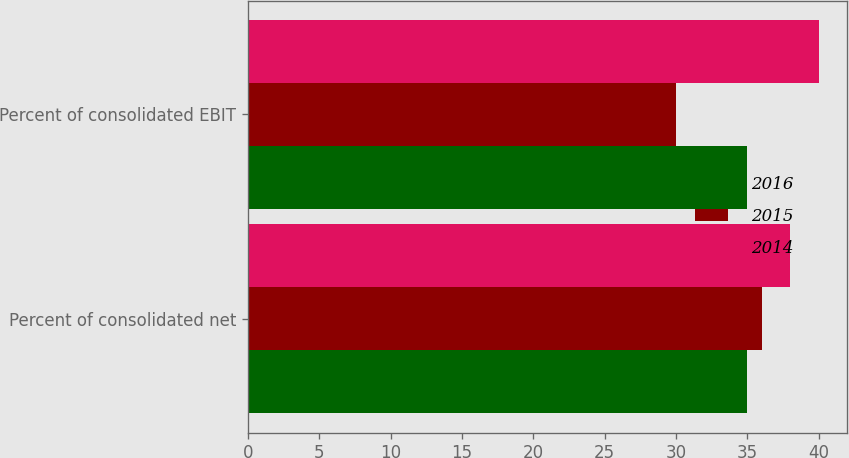Convert chart to OTSL. <chart><loc_0><loc_0><loc_500><loc_500><stacked_bar_chart><ecel><fcel>Percent of consolidated net<fcel>Percent of consolidated EBIT<nl><fcel>2016<fcel>35<fcel>35<nl><fcel>2015<fcel>36<fcel>30<nl><fcel>2014<fcel>38<fcel>40<nl></chart> 